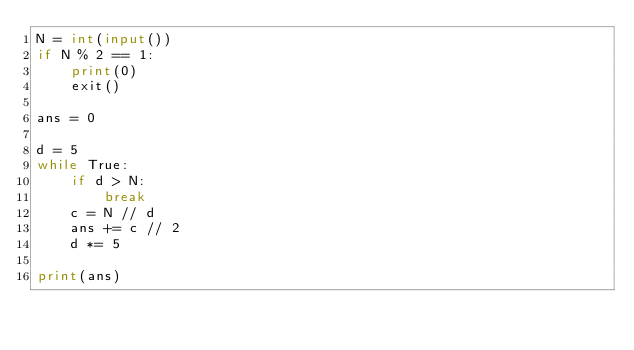Convert code to text. <code><loc_0><loc_0><loc_500><loc_500><_Python_>N = int(input())
if N % 2 == 1:
    print(0)
    exit()

ans = 0

d = 5
while True:
    if d > N:
        break
    c = N // d
    ans += c // 2
    d *= 5

print(ans)</code> 